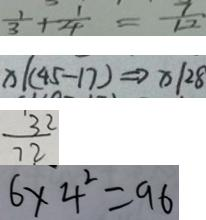Convert formula to latex. <formula><loc_0><loc_0><loc_500><loc_500>\frac { 1 } { 3 } + \frac { 1 } { 4 } = \frac { 7 } { 1 2 } 
 x \vert ( 4 5 - 1 7 ) \Rightarrow x \vert 2 8 
 \frac { 3 2 } { 7 2 } 
 6 \times 4 ^ { 2 } = 9 6</formula> 